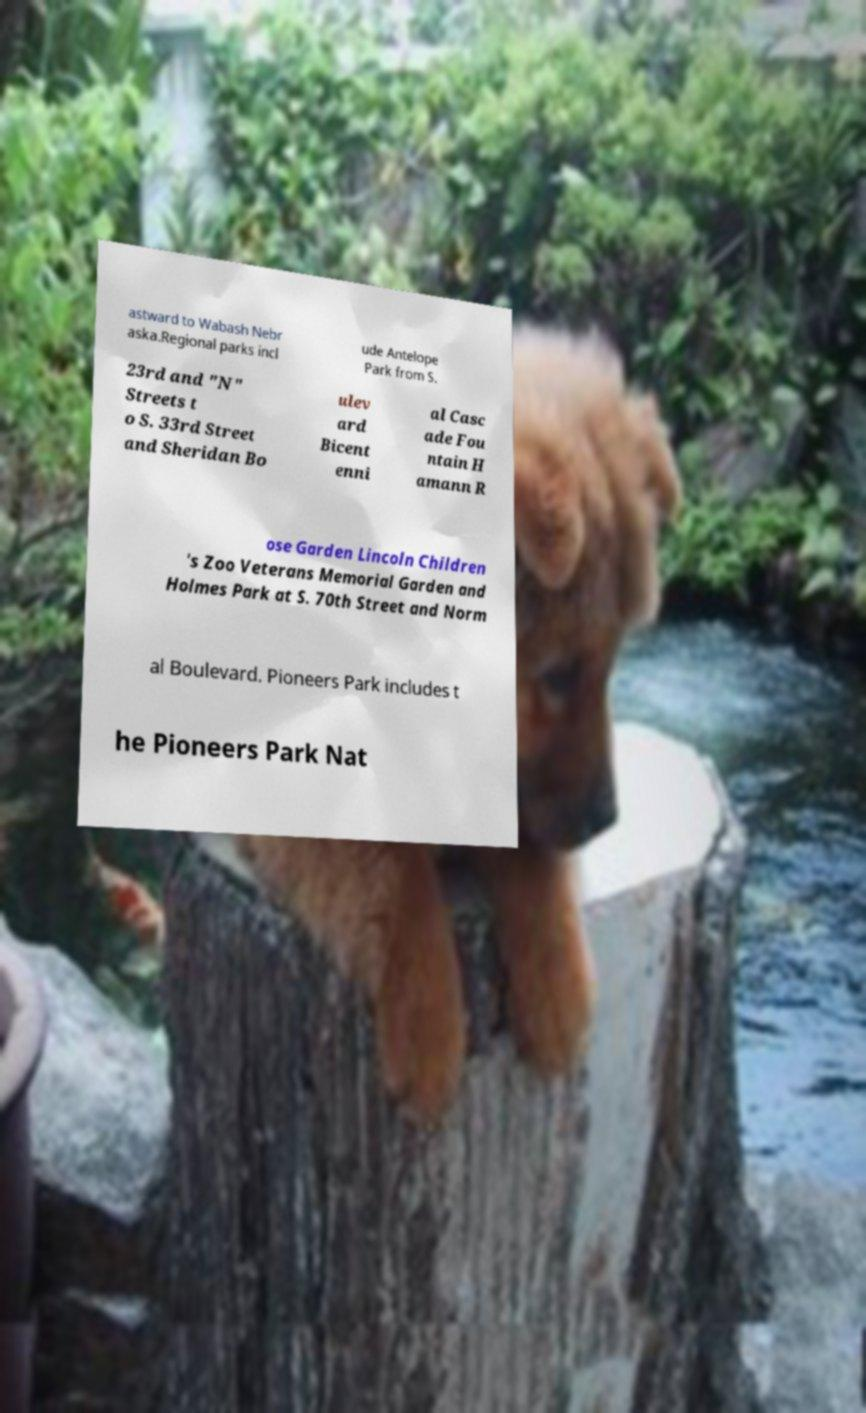Please identify and transcribe the text found in this image. astward to Wabash Nebr aska.Regional parks incl ude Antelope Park from S. 23rd and "N" Streets t o S. 33rd Street and Sheridan Bo ulev ard Bicent enni al Casc ade Fou ntain H amann R ose Garden Lincoln Children 's Zoo Veterans Memorial Garden and Holmes Park at S. 70th Street and Norm al Boulevard. Pioneers Park includes t he Pioneers Park Nat 